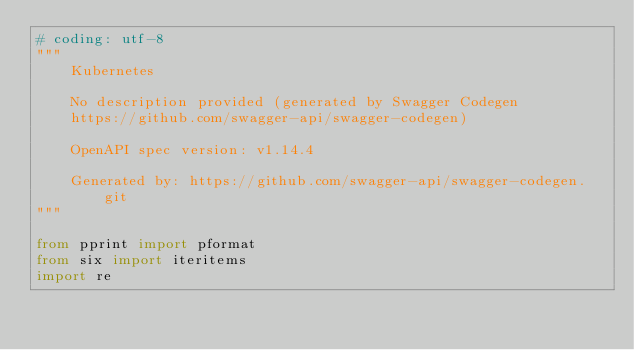<code> <loc_0><loc_0><loc_500><loc_500><_Python_># coding: utf-8
"""
    Kubernetes

    No description provided (generated by Swagger Codegen
    https://github.com/swagger-api/swagger-codegen)

    OpenAPI spec version: v1.14.4

    Generated by: https://github.com/swagger-api/swagger-codegen.git
"""

from pprint import pformat
from six import iteritems
import re

</code> 